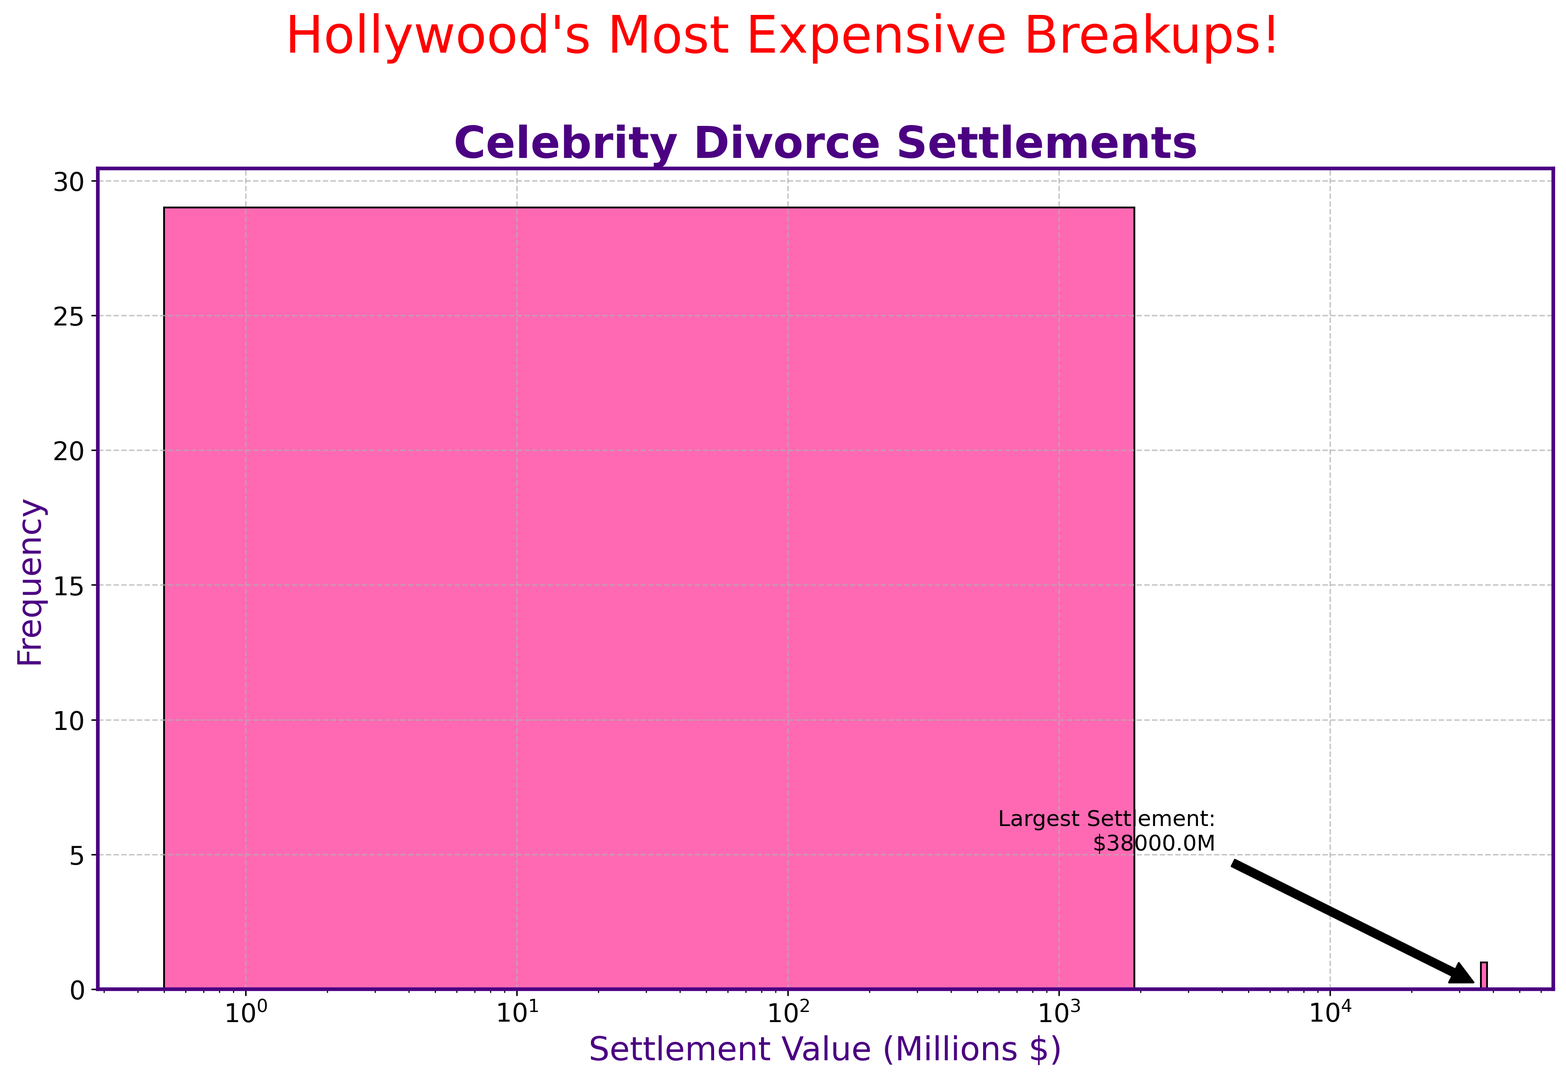Can you identify the celebrity divorce with the highest settlement value? The text annotation in the chart indicates the largest settlement. It points to the value of $38,000 million for Jeff Bezos and MacKenzie Scott.
Answer: Jeff Bezos and MacKenzie Scott What is the range of settlement values in the histograms? The range is the difference between the highest and lowest settlement values. The highest settlement value is $38,000 million (Jeff Bezos and MacKenzie Scott) and the lowest is $0.5 million (Kim Kardashian and Kris Humphries). So, the range is $38,000M - $0.5M = $37,999.5M.
Answer: $37,999.5 million How many divorces had settlements greater than $1 billion? By looking at the bins and the x-axis on the log scale, we can count the bars representing settlements above $1 billion. There are two such settlements (Jeff Bezos & MacKenzie Scott and Rupert Murdoch & Anna Torv).
Answer: 2 Between $10 million and $100 million, how many divorce settlements are there? Locate the bins representing the range $10 million - $100 million on the x-axis and count the corresponding bars. There are several such settlements (Madonna & Guy Ritchie, Harrison Ford & Melissa Mathison, Kevin Costner & Cindy Silva, Kenny Rogers & Marianne Gordon, James Cameron & Linda Hamilton, Michael Douglas & Diandra Douglas, Paul McCartney & Heather Mills, Kelsey Grammer & Camille Grammer, Lionel Richie & Diane Alexander).
Answer: 9 Which settlement value range has the highest frequency of occurrences? Evaluate the heights of the histogram bars. The tallest bar indicates the range with the highest frequency. The range around a few million seems to have the highest number of settlements.
Answer: Few millions How does the settlement of Michael Jordan and Juanita Vanoy compare to Steven Spielberg and Amy Irving? Michael Jordan and Juanita Vanoy had a settlement of $168 million, whereas Steven Spielberg and Amy Irving had a settlement of $100 million. We compare the values directly from the data.
Answer: Michael Jordan and Juanita Vanoy had a larger settlement What's the average value of divorce settlements listed? Sum all the settlement values and then divide by the number of settlements. The sum is $40,881.9 million and there are 28 settlements, so the average is $40,881.9/28 ≈ $1,460 million.
Answer: $1,460 million What proportion of the settlements are equal to or less than $10 million? Count the number of settlements under $10 million by looking at the bins on the histogram, then divide by the total number of settlements. There are 8 such settlements ($4.8M, $1M, $5M, $1.5M, $0.5M, $7M, $14M, $5M) out of 28, so the proportion is 8/28 ≈ 0.286 or 28.6%.
Answer: 28.6% 